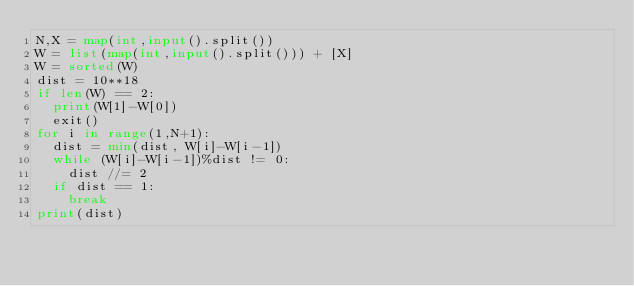<code> <loc_0><loc_0><loc_500><loc_500><_Python_>N,X = map(int,input().split())
W = list(map(int,input().split())) + [X]
W = sorted(W)
dist = 10**18
if len(W) == 2:
  print(W[1]-W[0])
  exit()
for i in range(1,N+1):
  dist = min(dist, W[i]-W[i-1])
  while (W[i]-W[i-1])%dist != 0:
    dist //= 2
  if dist == 1:
    break
print(dist)</code> 